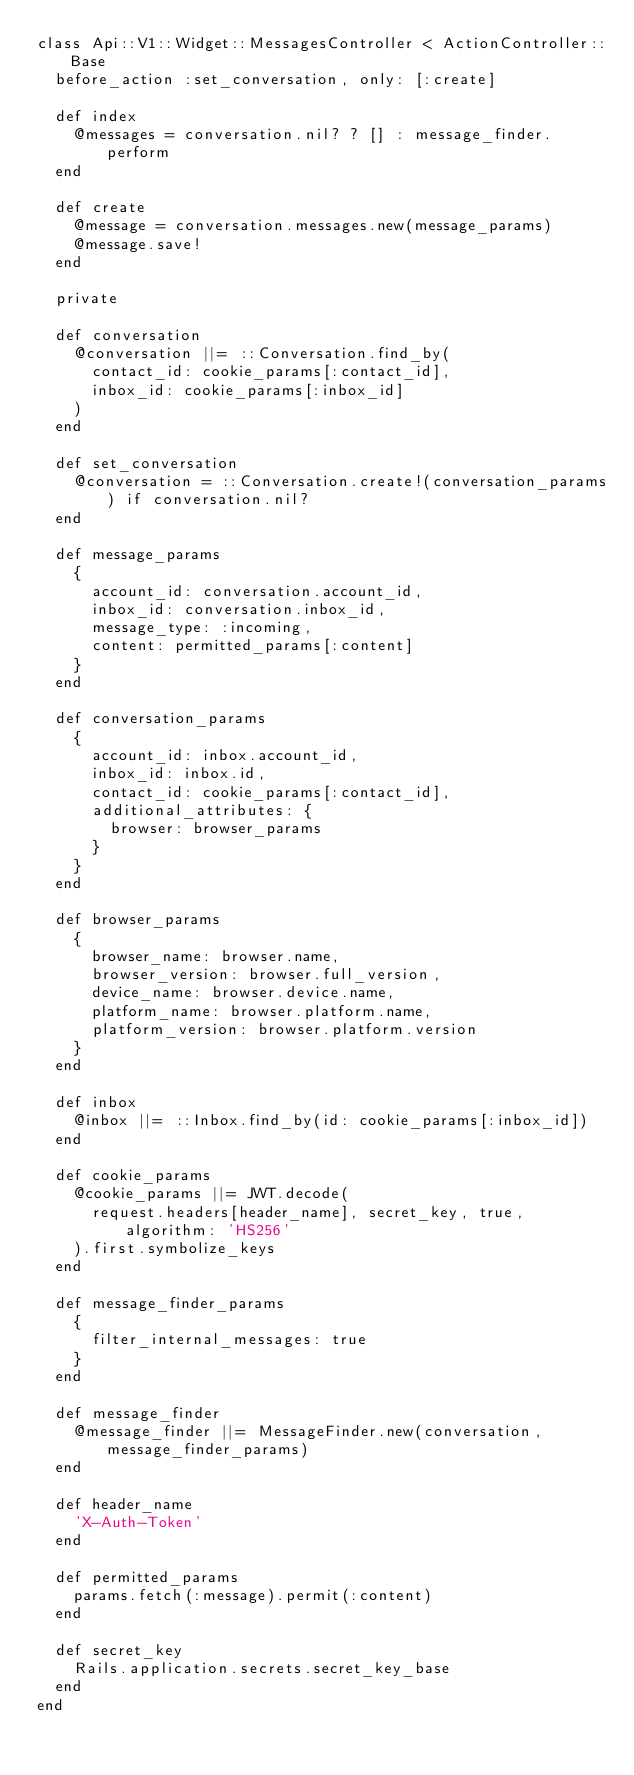Convert code to text. <code><loc_0><loc_0><loc_500><loc_500><_Ruby_>class Api::V1::Widget::MessagesController < ActionController::Base
  before_action :set_conversation, only: [:create]

  def index
    @messages = conversation.nil? ? [] : message_finder.perform
  end

  def create
    @message = conversation.messages.new(message_params)
    @message.save!
  end

  private

  def conversation
    @conversation ||= ::Conversation.find_by(
      contact_id: cookie_params[:contact_id],
      inbox_id: cookie_params[:inbox_id]
    )
  end

  def set_conversation
    @conversation = ::Conversation.create!(conversation_params) if conversation.nil?
  end

  def message_params
    {
      account_id: conversation.account_id,
      inbox_id: conversation.inbox_id,
      message_type: :incoming,
      content: permitted_params[:content]
    }
  end

  def conversation_params
    {
      account_id: inbox.account_id,
      inbox_id: inbox.id,
      contact_id: cookie_params[:contact_id],
      additional_attributes: {
        browser: browser_params
      }
    }
  end

  def browser_params
    {
      browser_name: browser.name,
      browser_version: browser.full_version,
      device_name: browser.device.name,
      platform_name: browser.platform.name,
      platform_version: browser.platform.version
    }
  end

  def inbox
    @inbox ||= ::Inbox.find_by(id: cookie_params[:inbox_id])
  end

  def cookie_params
    @cookie_params ||= JWT.decode(
      request.headers[header_name], secret_key, true, algorithm: 'HS256'
    ).first.symbolize_keys
  end

  def message_finder_params
    {
      filter_internal_messages: true
    }
  end

  def message_finder
    @message_finder ||= MessageFinder.new(conversation, message_finder_params)
  end

  def header_name
    'X-Auth-Token'
  end

  def permitted_params
    params.fetch(:message).permit(:content)
  end

  def secret_key
    Rails.application.secrets.secret_key_base
  end
end
</code> 